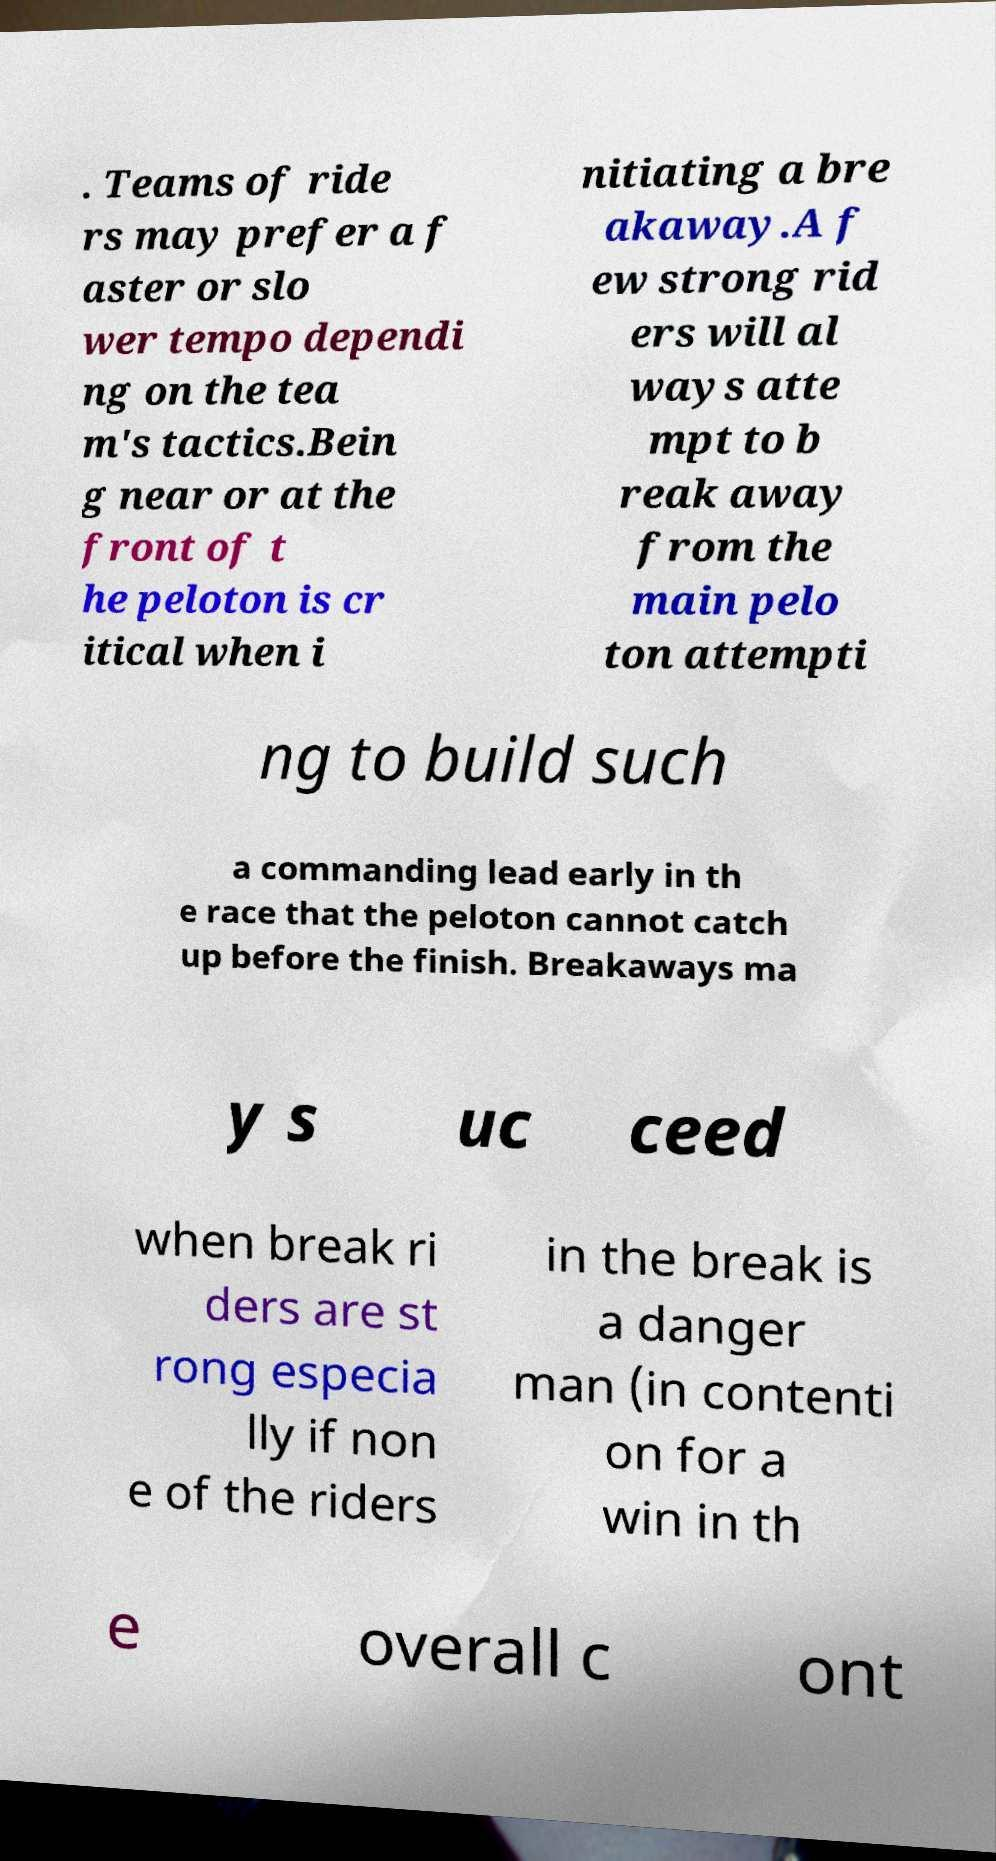Please identify and transcribe the text found in this image. . Teams of ride rs may prefer a f aster or slo wer tempo dependi ng on the tea m's tactics.Bein g near or at the front of t he peloton is cr itical when i nitiating a bre akaway.A f ew strong rid ers will al ways atte mpt to b reak away from the main pelo ton attempti ng to build such a commanding lead early in th e race that the peloton cannot catch up before the finish. Breakaways ma y s uc ceed when break ri ders are st rong especia lly if non e of the riders in the break is a danger man (in contenti on for a win in th e overall c ont 